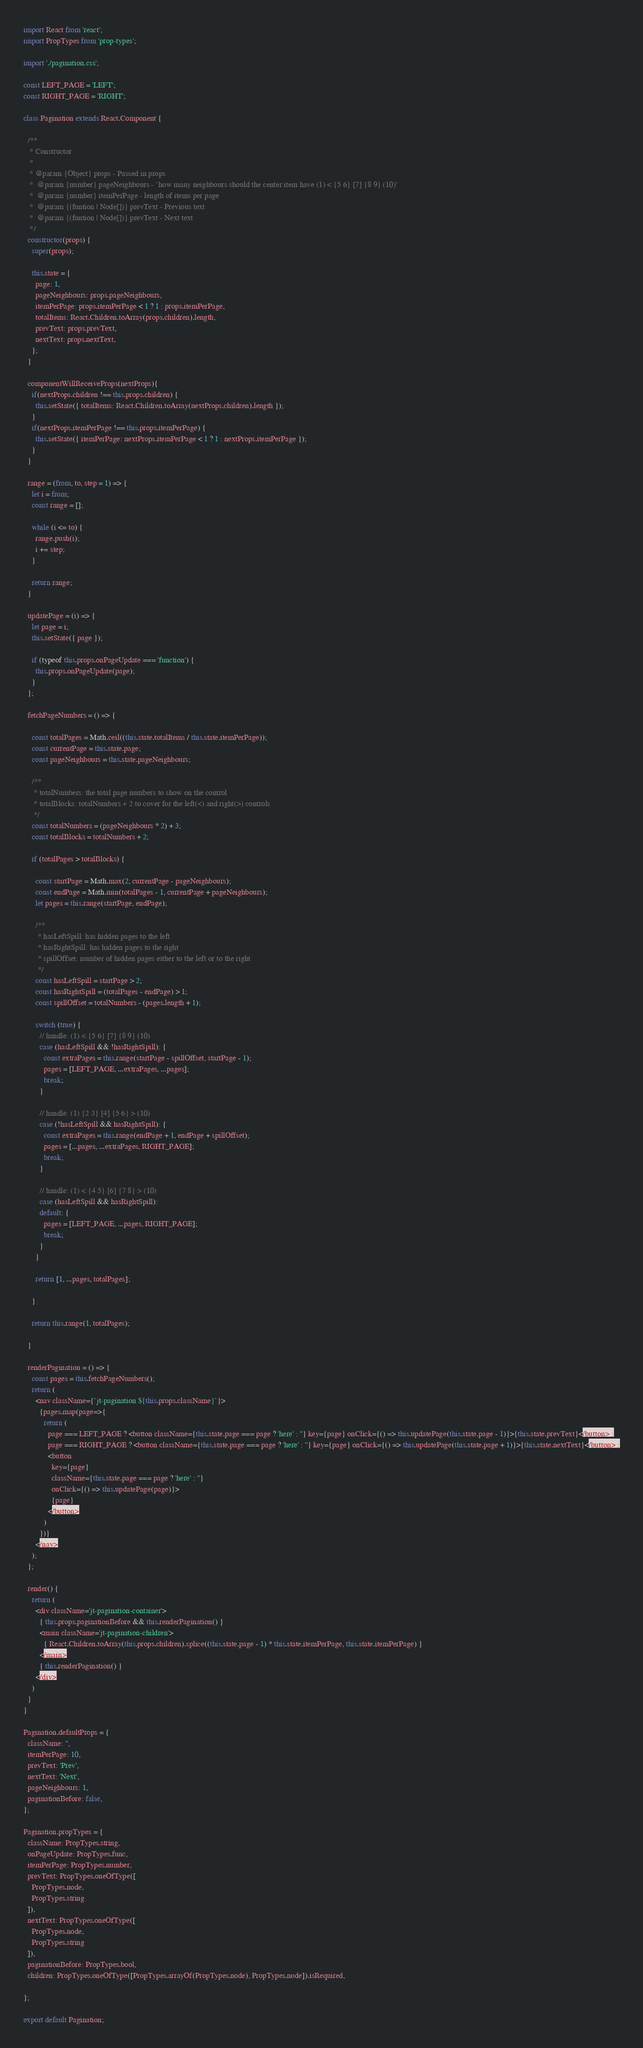Convert code to text. <code><loc_0><loc_0><loc_500><loc_500><_JavaScript_>import React from 'react';
import PropTypes from 'prop-types';

import './pagination.css';

const LEFT_PAGE = 'LEFT';
const RIGHT_PAGE = 'RIGHT';

class Pagination extends React.Component {

  /**
   * Constructor
   * 
   * @param {Object} props - Passed in props
   *  @param {number} pageNeighbours - `how many neighbours should the center item have (1) < {5 6} [7] {8 9} (10)`
   *  @param {number} itemPerPage - length of items per page
   *  @param {(funtion | Node[])} prevText - Previous text
   *  @param {(funtion | Node[])} prevText - Next text
   */  
  constructor(props) {
    super(props);

    this.state = {
      page: 1,
      pageNeighbours: props.pageNeighbours,
      itemPerPage: props.itemPerPage < 1 ? 1 : props.itemPerPage,
      totalItems: React.Children.toArray(props.children).length,
      prevText: props.prevText,
      nextText: props.nextText,
    };
  }

  componentWillReceiveProps(nextProps){
    if(nextProps.children !== this.props.children) {
      this.setState({ totalItems: React.Children.toArray(nextProps.children).length });
    }
    if(nextProps.itemPerPage !== this.props.itemPerPage) {
      this.setState({ itemPerPage: nextProps.itemPerPage < 1 ? 1 : nextProps.itemPerPage });
    }
  }

  range = (from, to, step = 1) => {
    let i = from;
    const range = [];
  
    while (i <= to) {
      range.push(i);
      i += step;
    }
  
    return range;
  }

  updatePage = (i) => {
    let page = i;
    this.setState({ page });

    if (typeof this.props.onPageUpdate === 'function') {
      this.props.onPageUpdate(page);
    }
  };

  fetchPageNumbers = () => {

    const totalPages = Math.ceil((this.state.totalItems / this.state.itemPerPage));
    const currentPage = this.state.page;
    const pageNeighbours = this.state.pageNeighbours;

    /**
     * totalNumbers: the total page numbers to show on the control
     * totalBlocks: totalNumbers + 2 to cover for the left(<) and right(>) controls
     */
    const totalNumbers = (pageNeighbours * 2) + 3;
    const totalBlocks = totalNumbers + 2;

    if (totalPages > totalBlocks) {

      const startPage = Math.max(2, currentPage - pageNeighbours);
      const endPage = Math.min(totalPages - 1, currentPage + pageNeighbours);
      let pages = this.range(startPage, endPage);

      /**
       * hasLeftSpill: has hidden pages to the left
       * hasRightSpill: has hidden pages to the right
       * spillOffset: number of hidden pages either to the left or to the right
       */
      const hasLeftSpill = startPage > 2;
      const hasRightSpill = (totalPages - endPage) > 1;
      const spillOffset = totalNumbers - (pages.length + 1);

      switch (true) {
        // handle: (1) < {5 6} [7] {8 9} (10)
        case (hasLeftSpill && !hasRightSpill): {
          const extraPages = this.range(startPage - spillOffset, startPage - 1);
          pages = [LEFT_PAGE, ...extraPages, ...pages];
          break;
        }

        // handle: (1) {2 3} [4] {5 6} > (10)
        case (!hasLeftSpill && hasRightSpill): {
          const extraPages = this.range(endPage + 1, endPage + spillOffset);
          pages = [...pages, ...extraPages, RIGHT_PAGE];
          break;
        }

        // handle: (1) < {4 5} [6] {7 8} > (10)
        case (hasLeftSpill && hasRightSpill):
        default: {
          pages = [LEFT_PAGE, ...pages, RIGHT_PAGE];
          break;
        }
      }

      return [1, ...pages, totalPages];

    }

    return this.range(1, totalPages);

  }

  renderPagination = () => {
    const pages = this.fetchPageNumbers();
    return (
      <nav className={`jt-pagination ${this.props.className}`}>
        {pages.map(page=>{
          return (
            page === LEFT_PAGE ? <button className={this.state.page === page ? 'here' : ''} key={page} onClick={() => this.updatePage(this.state.page - 1)}>{this.state.prevText}</button> :
            page === RIGHT_PAGE ? <button className={this.state.page === page ? 'here' : ''} key={page} onClick={() => this.updatePage(this.state.page + 1)}>{this.state.nextText}</button> :
            <button
              key={page}
              className={this.state.page === page ? 'here' : ''}
              onClick={() => this.updatePage(page)}>
              {page}
            </button>
          )
        })}
      </nav>
    );
  };

  render() {
    return (
      <div className='jt-pagination-container'>
        { this.props.paginationBefore && this.renderPagination() }
        <main className='jt-pagination-children'>
          { React.Children.toArray(this.props.children).splice((this.state.page - 1) * this.state.itemPerPage, this.state.itemPerPage) }
        </main>
        { this.renderPagination() }
      </div>
    )
  }
}

Pagination.defaultProps = {
  className: '',
  itemPerPage: 10,
  prevText: 'Prev',
  nextText: 'Next',
  pageNeighbours: 1,
  paginationBefore: false,
};

Pagination.propTypes = {
  className: PropTypes.string,
  onPageUpdate: PropTypes.func,
  itemPerPage: PropTypes.number,
  prevText: PropTypes.oneOfType([
    PropTypes.node,
    PropTypes.string
  ]),
  nextText: PropTypes.oneOfType([
    PropTypes.node,
    PropTypes.string
  ]),
  paginationBefore: PropTypes.bool,
  children: PropTypes.oneOfType([PropTypes.arrayOf(PropTypes.node), PropTypes.node]).isRequired,

};

export default Pagination;
</code> 